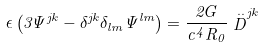Convert formula to latex. <formula><loc_0><loc_0><loc_500><loc_500>\epsilon \left ( 3 \Psi ^ { j k } - \delta ^ { j k } \delta _ { l m } \Psi ^ { l m } \right ) = \frac { 2 G } { c ^ { 4 } R _ { 0 } } \stackrel { . . } { D } ^ { j k }</formula> 